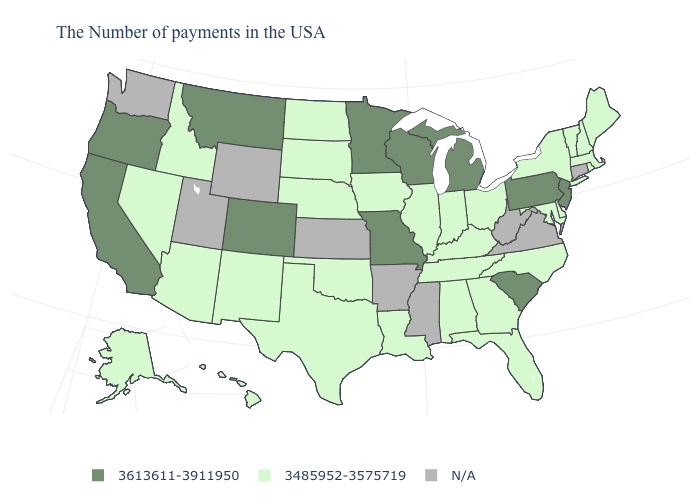What is the value of Delaware?
Short answer required. 3485952-3575719. Is the legend a continuous bar?
Give a very brief answer. No. Name the states that have a value in the range N/A?
Concise answer only. Connecticut, Virginia, West Virginia, Mississippi, Arkansas, Kansas, Wyoming, Utah, Washington. Does the map have missing data?
Keep it brief. Yes. What is the value of Iowa?
Quick response, please. 3485952-3575719. Name the states that have a value in the range 3613611-3911950?
Answer briefly. New Jersey, Pennsylvania, South Carolina, Michigan, Wisconsin, Missouri, Minnesota, Colorado, Montana, California, Oregon. Name the states that have a value in the range 3613611-3911950?
Quick response, please. New Jersey, Pennsylvania, South Carolina, Michigan, Wisconsin, Missouri, Minnesota, Colorado, Montana, California, Oregon. What is the value of Oklahoma?
Be succinct. 3485952-3575719. What is the value of Delaware?
Be succinct. 3485952-3575719. Name the states that have a value in the range N/A?
Short answer required. Connecticut, Virginia, West Virginia, Mississippi, Arkansas, Kansas, Wyoming, Utah, Washington. Does South Carolina have the highest value in the South?
Write a very short answer. Yes. What is the value of New York?
Short answer required. 3485952-3575719. 